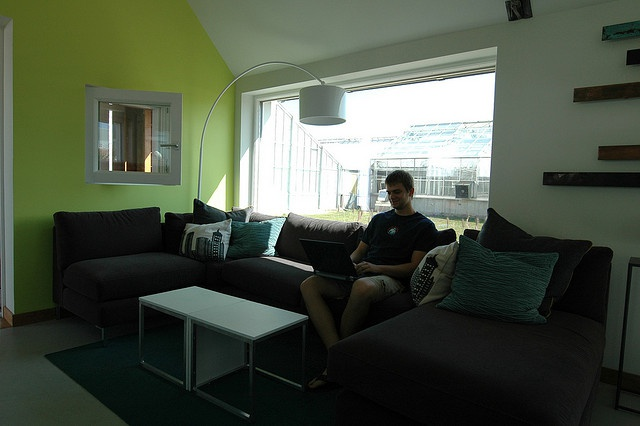Describe the objects in this image and their specific colors. I can see couch in darkgreen, black, gray, and khaki tones, chair in darkgreen, black, gray, and green tones, couch in darkgreen, black, gray, darkgray, and teal tones, people in darkgreen, black, and gray tones, and laptop in darkgreen, black, and gray tones in this image. 